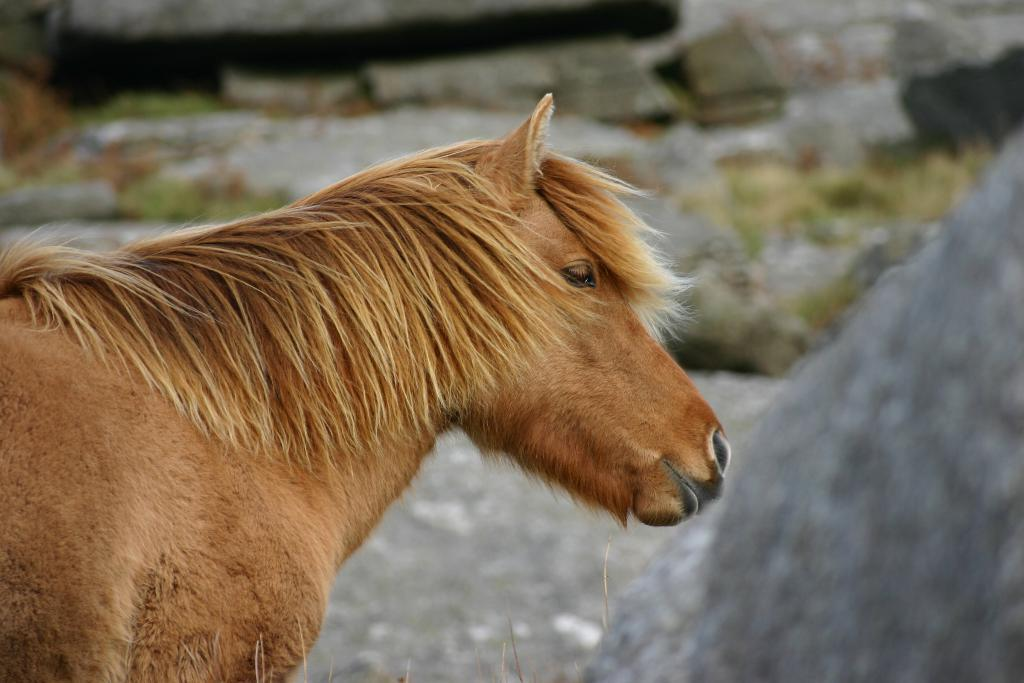What is the main subject of the image? The main subject of the image is a horse. Where is the horse located in the image? The horse is in the front of the image. How would you describe the background of the image? The background of the image is blurry. What type of plants can be seen growing on the sofa in the image? There is no sofa or plants present in the image, so it's not possible to answer that question. 